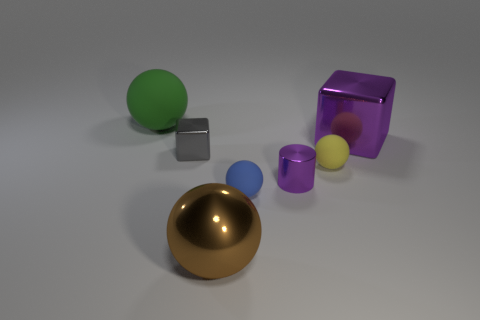Add 2 brown metallic spheres. How many objects exist? 9 Subtract all rubber spheres. How many spheres are left? 1 Subtract 1 spheres. How many spheres are left? 3 Subtract all gray cubes. How many cubes are left? 1 Add 5 large shiny cubes. How many large shiny cubes are left? 6 Add 2 yellow spheres. How many yellow spheres exist? 3 Subtract 1 purple cylinders. How many objects are left? 6 Subtract all cylinders. How many objects are left? 6 Subtract all gray balls. Subtract all green cubes. How many balls are left? 4 Subtract all gray cubes. How many blue cylinders are left? 0 